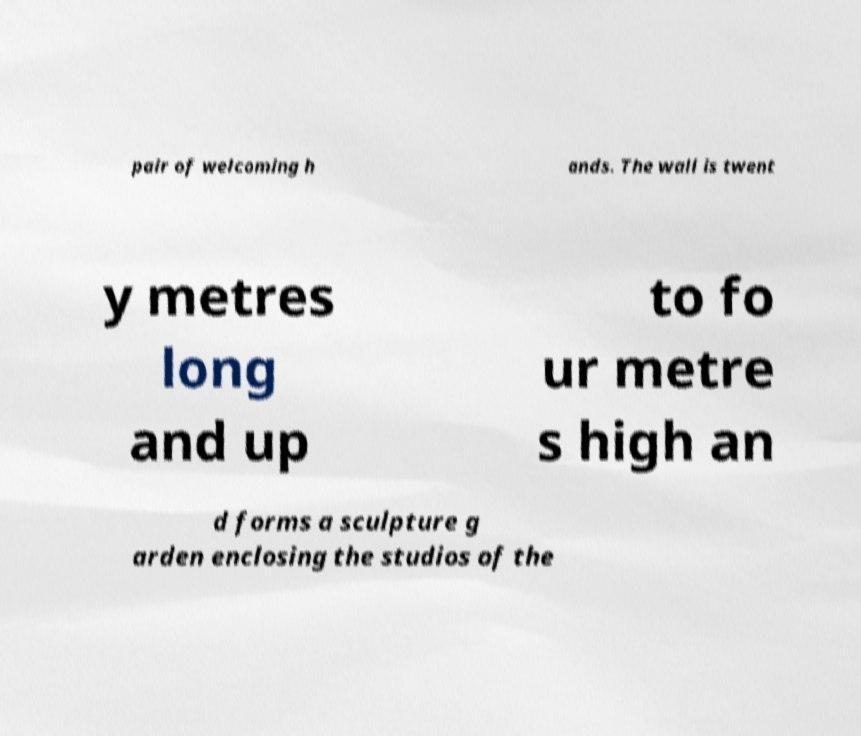Can you read and provide the text displayed in the image?This photo seems to have some interesting text. Can you extract and type it out for me? pair of welcoming h ands. The wall is twent y metres long and up to fo ur metre s high an d forms a sculpture g arden enclosing the studios of the 